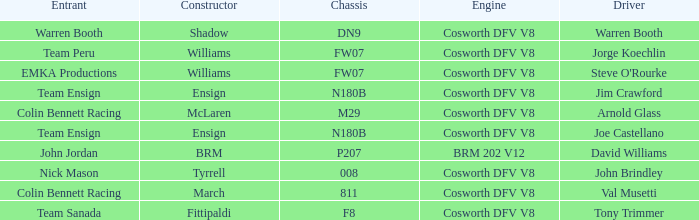Who built Warren Booth's car with the Cosworth DFV V8 engine? Shadow. 